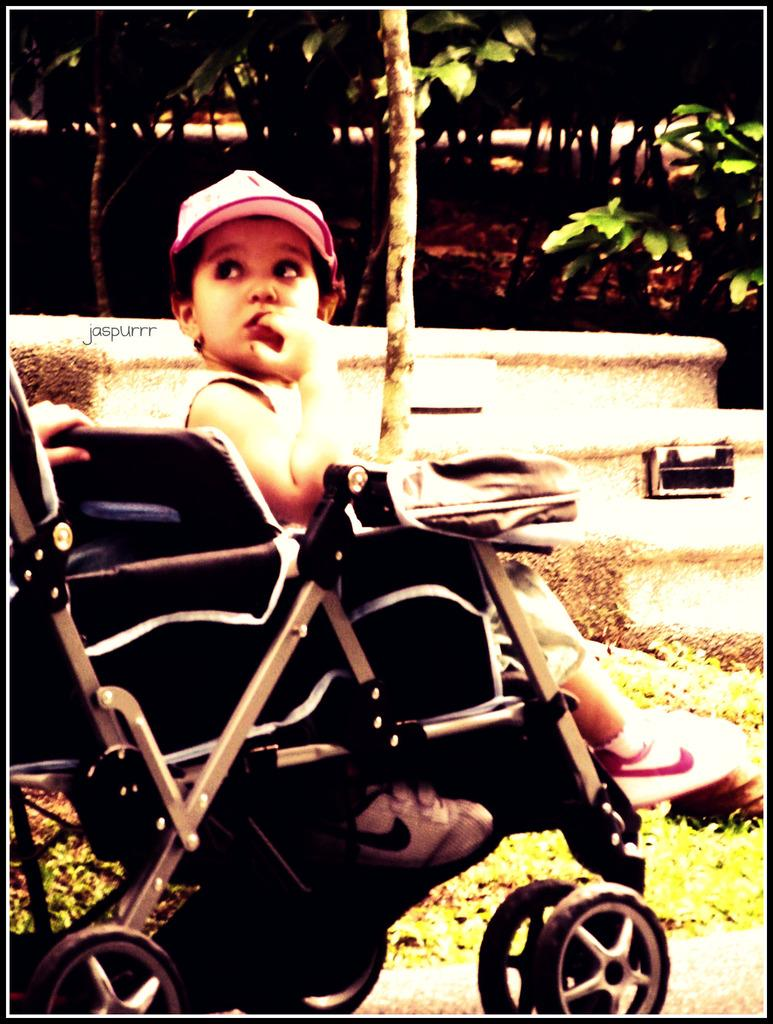What is the main subject of the image? The main subject of the image is a kid sitting in a baby stroller. What can be seen in the background of the image? There are trees in the background of the image. Can you describe anything on the left side of the image? A human hand is visible on the left side of the image. How many oranges are visible in the image? There are no oranges present in the image. 